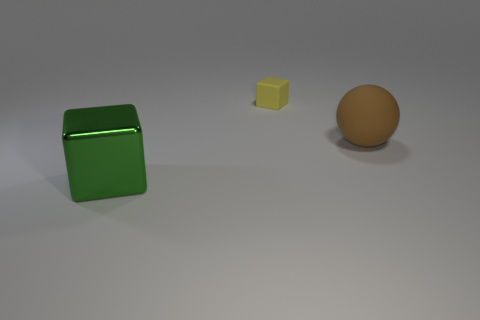Add 3 green objects. How many objects exist? 6 Subtract all yellow blocks. How many blocks are left? 1 Subtract 1 yellow cubes. How many objects are left? 2 Subtract all blocks. How many objects are left? 1 Subtract 1 cubes. How many cubes are left? 1 Subtract all blue spheres. Subtract all blue blocks. How many spheres are left? 1 Subtract all big green cylinders. Subtract all big brown objects. How many objects are left? 2 Add 2 big green metallic objects. How many big green metallic objects are left? 3 Add 2 yellow blocks. How many yellow blocks exist? 3 